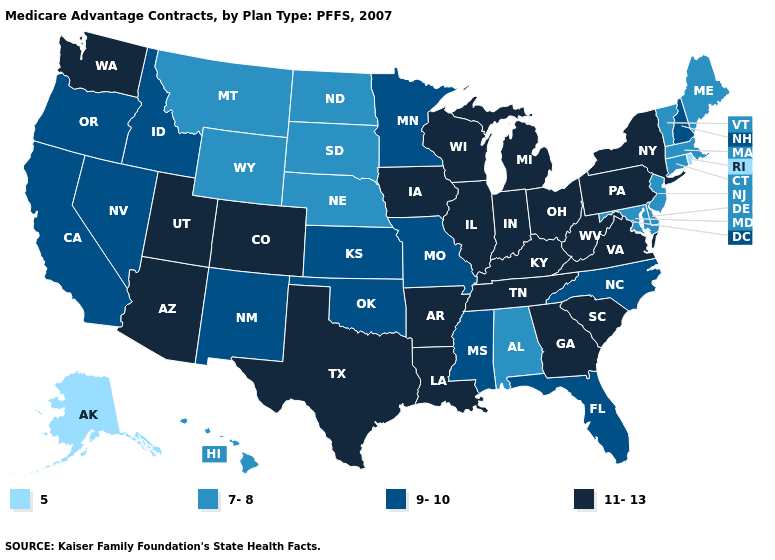What is the lowest value in states that border South Carolina?
Give a very brief answer. 9-10. What is the highest value in the MidWest ?
Short answer required. 11-13. What is the value of Arizona?
Be succinct. 11-13. What is the highest value in states that border New Jersey?
Be succinct. 11-13. Does Missouri have the highest value in the MidWest?
Keep it brief. No. What is the value of Arizona?
Concise answer only. 11-13. Does the map have missing data?
Short answer required. No. Does Indiana have the lowest value in the MidWest?
Give a very brief answer. No. Among the states that border California , does Arizona have the highest value?
Be succinct. Yes. Name the states that have a value in the range 5?
Concise answer only. Alaska, Rhode Island. Name the states that have a value in the range 5?
Answer briefly. Alaska, Rhode Island. Name the states that have a value in the range 11-13?
Keep it brief. Arkansas, Arizona, Colorado, Georgia, Iowa, Illinois, Indiana, Kentucky, Louisiana, Michigan, New York, Ohio, Pennsylvania, South Carolina, Tennessee, Texas, Utah, Virginia, Washington, Wisconsin, West Virginia. Which states have the lowest value in the USA?
Write a very short answer. Alaska, Rhode Island. Name the states that have a value in the range 7-8?
Concise answer only. Alabama, Connecticut, Delaware, Hawaii, Massachusetts, Maryland, Maine, Montana, North Dakota, Nebraska, New Jersey, South Dakota, Vermont, Wyoming. 